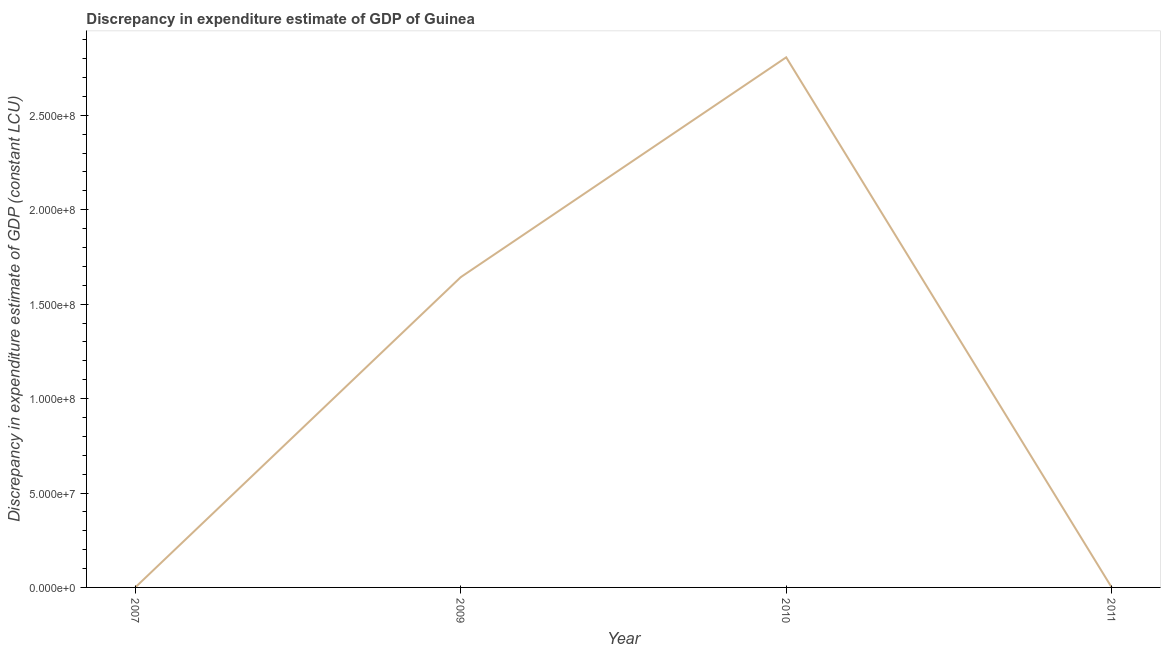What is the discrepancy in expenditure estimate of gdp in 2009?
Your response must be concise. 1.64e+08. Across all years, what is the maximum discrepancy in expenditure estimate of gdp?
Keep it short and to the point. 2.81e+08. Across all years, what is the minimum discrepancy in expenditure estimate of gdp?
Your response must be concise. 100. In which year was the discrepancy in expenditure estimate of gdp minimum?
Offer a terse response. 2007. What is the sum of the discrepancy in expenditure estimate of gdp?
Keep it short and to the point. 4.45e+08. What is the difference between the discrepancy in expenditure estimate of gdp in 2009 and 2011?
Offer a terse response. 1.64e+08. What is the average discrepancy in expenditure estimate of gdp per year?
Your response must be concise. 1.11e+08. What is the median discrepancy in expenditure estimate of gdp?
Ensure brevity in your answer.  8.21e+07. What is the ratio of the discrepancy in expenditure estimate of gdp in 2010 to that in 2011?
Make the answer very short. 2.81e+06. What is the difference between the highest and the second highest discrepancy in expenditure estimate of gdp?
Provide a short and direct response. 1.16e+08. What is the difference between the highest and the lowest discrepancy in expenditure estimate of gdp?
Provide a short and direct response. 2.81e+08. In how many years, is the discrepancy in expenditure estimate of gdp greater than the average discrepancy in expenditure estimate of gdp taken over all years?
Your answer should be very brief. 2. Does the discrepancy in expenditure estimate of gdp monotonically increase over the years?
Provide a succinct answer. No. How many lines are there?
Keep it short and to the point. 1. What is the difference between two consecutive major ticks on the Y-axis?
Your answer should be very brief. 5.00e+07. Does the graph contain any zero values?
Offer a very short reply. No. What is the title of the graph?
Keep it short and to the point. Discrepancy in expenditure estimate of GDP of Guinea. What is the label or title of the X-axis?
Your answer should be very brief. Year. What is the label or title of the Y-axis?
Make the answer very short. Discrepancy in expenditure estimate of GDP (constant LCU). What is the Discrepancy in expenditure estimate of GDP (constant LCU) of 2009?
Give a very brief answer. 1.64e+08. What is the Discrepancy in expenditure estimate of GDP (constant LCU) of 2010?
Give a very brief answer. 2.81e+08. What is the Discrepancy in expenditure estimate of GDP (constant LCU) of 2011?
Your response must be concise. 100. What is the difference between the Discrepancy in expenditure estimate of GDP (constant LCU) in 2007 and 2009?
Provide a short and direct response. -1.64e+08. What is the difference between the Discrepancy in expenditure estimate of GDP (constant LCU) in 2007 and 2010?
Make the answer very short. -2.81e+08. What is the difference between the Discrepancy in expenditure estimate of GDP (constant LCU) in 2007 and 2011?
Keep it short and to the point. 0. What is the difference between the Discrepancy in expenditure estimate of GDP (constant LCU) in 2009 and 2010?
Provide a succinct answer. -1.16e+08. What is the difference between the Discrepancy in expenditure estimate of GDP (constant LCU) in 2009 and 2011?
Ensure brevity in your answer.  1.64e+08. What is the difference between the Discrepancy in expenditure estimate of GDP (constant LCU) in 2010 and 2011?
Make the answer very short. 2.81e+08. What is the ratio of the Discrepancy in expenditure estimate of GDP (constant LCU) in 2007 to that in 2011?
Offer a very short reply. 1. What is the ratio of the Discrepancy in expenditure estimate of GDP (constant LCU) in 2009 to that in 2010?
Make the answer very short. 0.58. What is the ratio of the Discrepancy in expenditure estimate of GDP (constant LCU) in 2009 to that in 2011?
Your answer should be very brief. 1.64e+06. What is the ratio of the Discrepancy in expenditure estimate of GDP (constant LCU) in 2010 to that in 2011?
Give a very brief answer. 2.81e+06. 